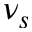Convert formula to latex. <formula><loc_0><loc_0><loc_500><loc_500>\nu _ { s }</formula> 